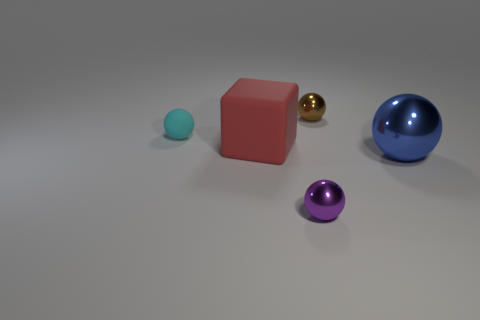Subtract 1 spheres. How many spheres are left? 3 Add 2 purple shiny spheres. How many objects exist? 7 Subtract all spheres. How many objects are left? 1 Add 4 small matte objects. How many small matte objects are left? 5 Add 4 metallic objects. How many metallic objects exist? 7 Subtract 0 blue blocks. How many objects are left? 5 Subtract all small purple objects. Subtract all tiny brown metallic objects. How many objects are left? 3 